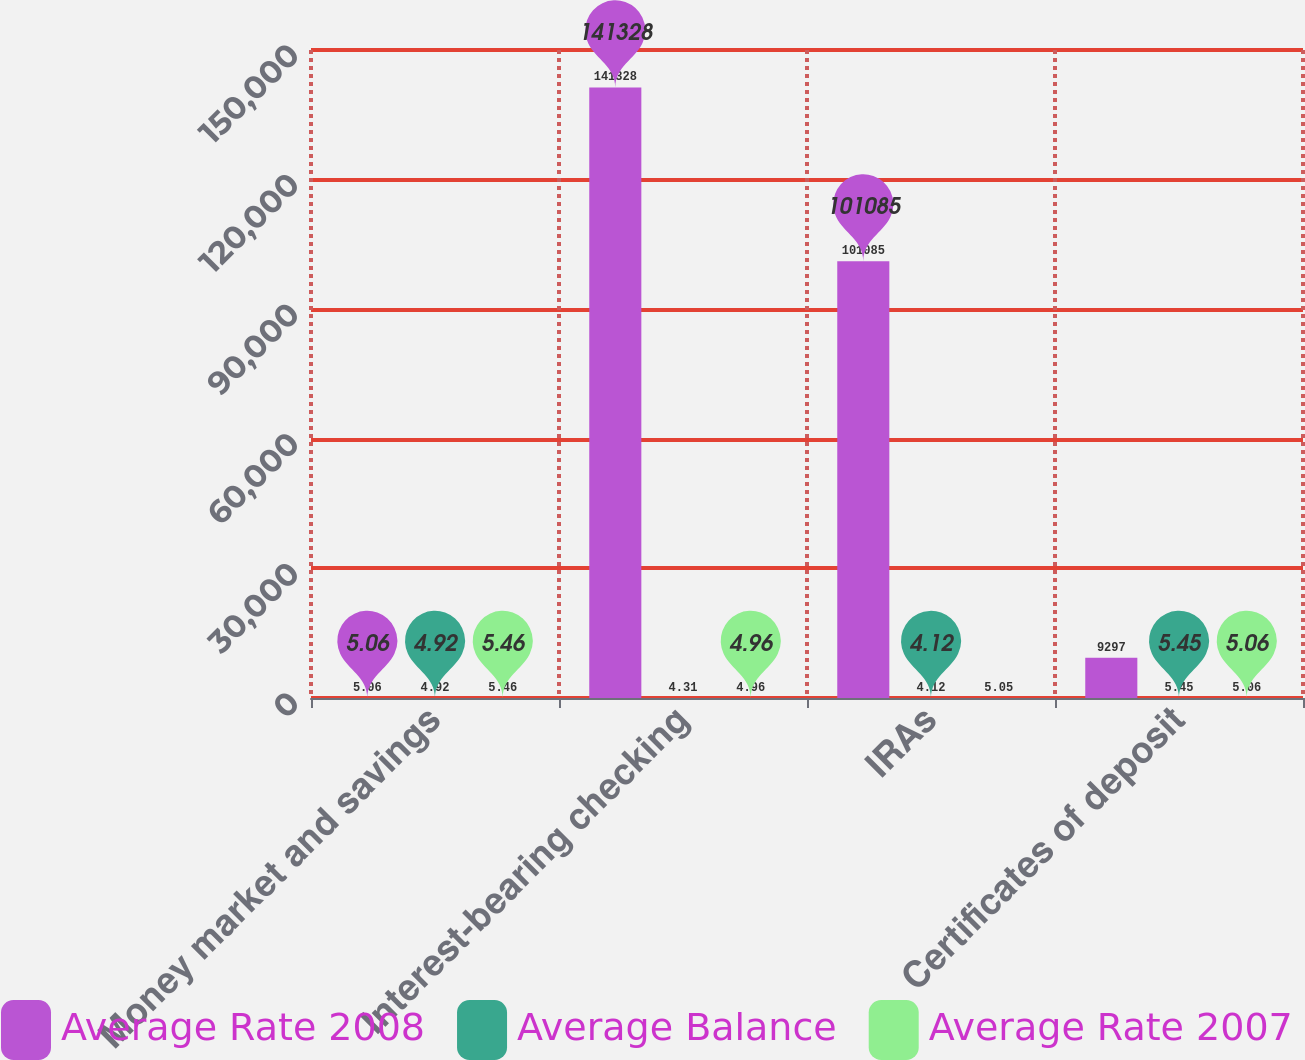Convert chart. <chart><loc_0><loc_0><loc_500><loc_500><stacked_bar_chart><ecel><fcel>Money market and savings<fcel>Interest-bearing checking<fcel>IRAs<fcel>Certificates of deposit<nl><fcel>Average Rate 2008<fcel>5.06<fcel>141328<fcel>101085<fcel>9297<nl><fcel>Average Balance<fcel>4.92<fcel>4.31<fcel>4.12<fcel>5.45<nl><fcel>Average Rate 2007<fcel>5.46<fcel>4.96<fcel>5.05<fcel>5.06<nl></chart> 